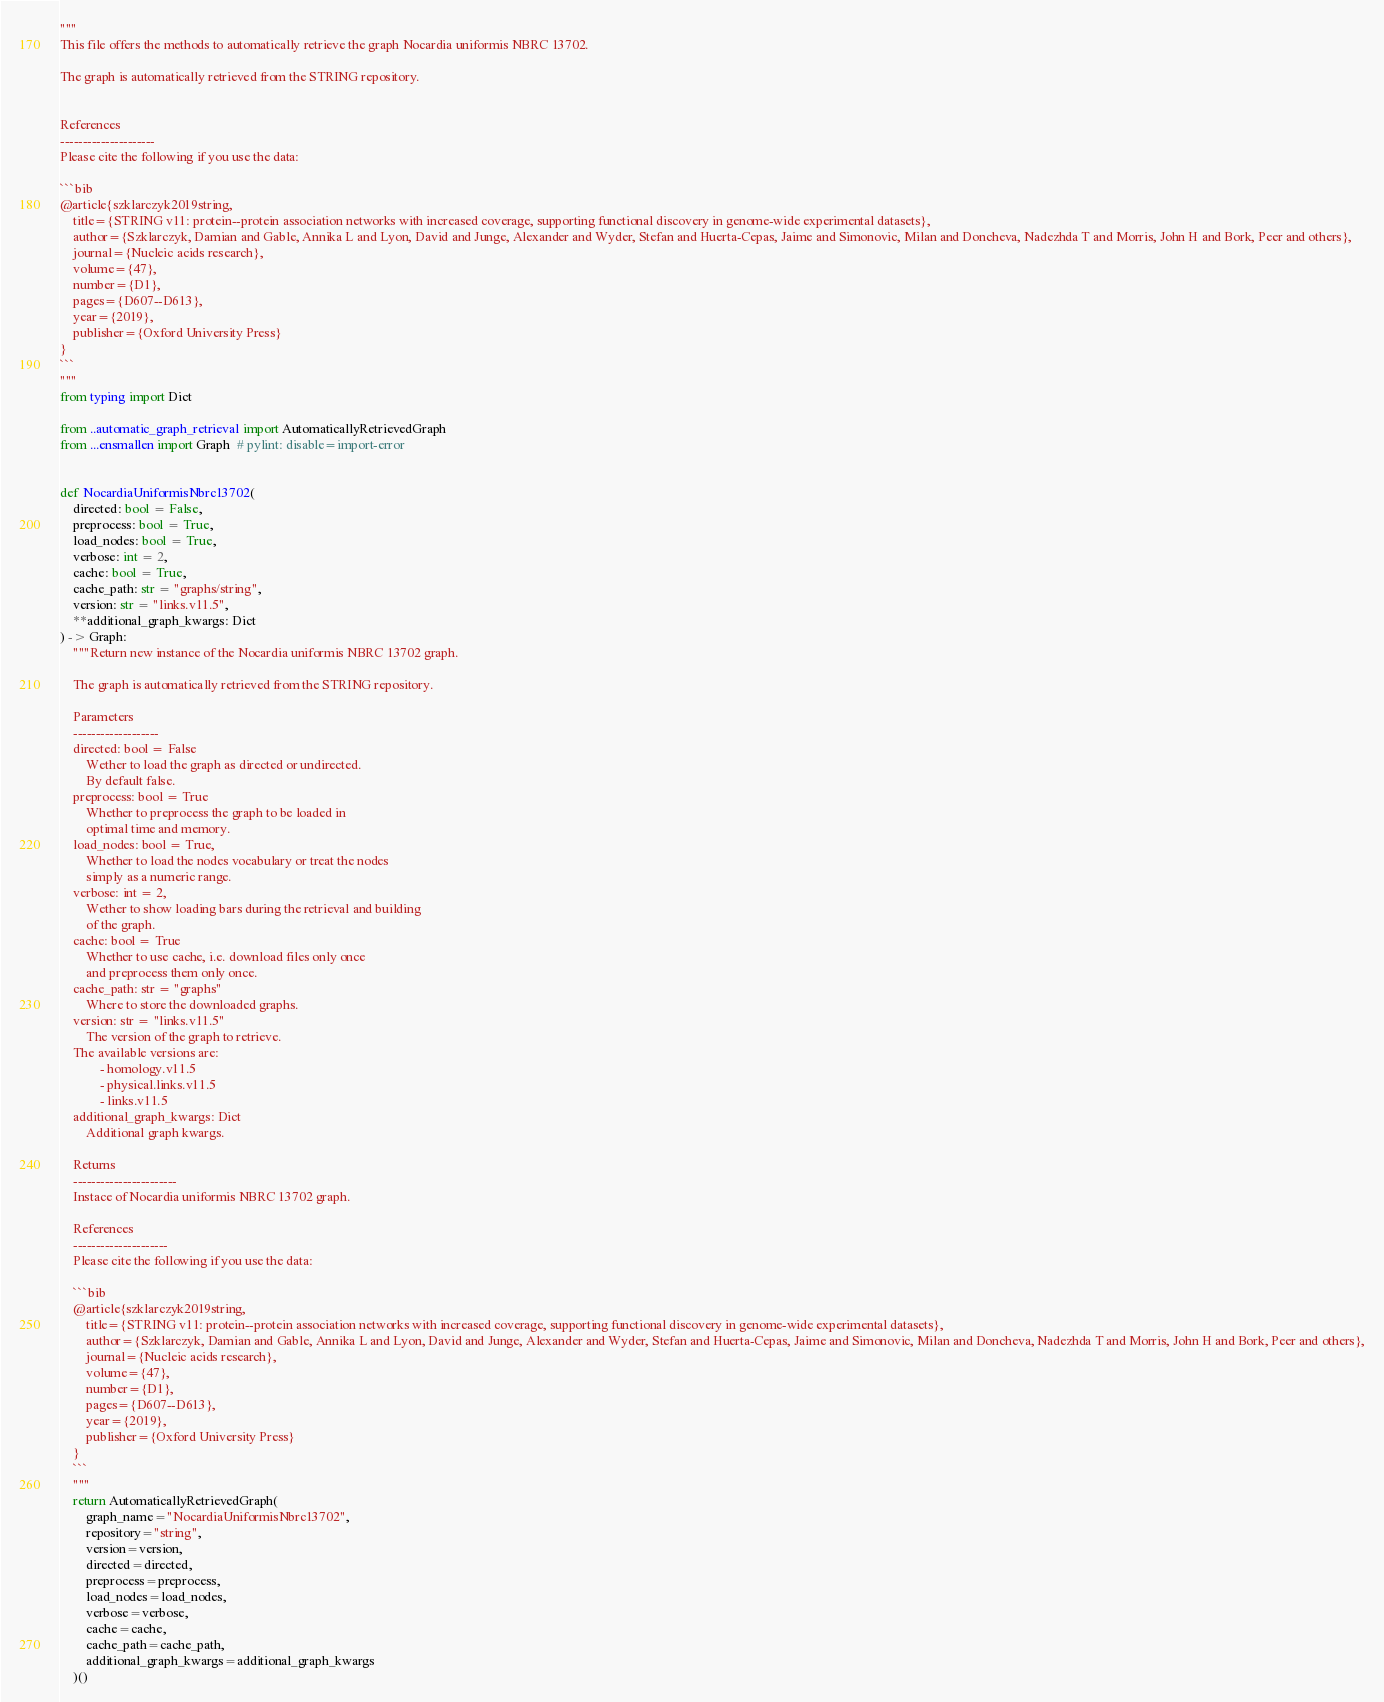<code> <loc_0><loc_0><loc_500><loc_500><_Python_>"""
This file offers the methods to automatically retrieve the graph Nocardia uniformis NBRC 13702.

The graph is automatically retrieved from the STRING repository. 


References
---------------------
Please cite the following if you use the data:

```bib
@article{szklarczyk2019string,
    title={STRING v11: protein--protein association networks with increased coverage, supporting functional discovery in genome-wide experimental datasets},
    author={Szklarczyk, Damian and Gable, Annika L and Lyon, David and Junge, Alexander and Wyder, Stefan and Huerta-Cepas, Jaime and Simonovic, Milan and Doncheva, Nadezhda T and Morris, John H and Bork, Peer and others},
    journal={Nucleic acids research},
    volume={47},
    number={D1},
    pages={D607--D613},
    year={2019},
    publisher={Oxford University Press}
}
```
"""
from typing import Dict

from ..automatic_graph_retrieval import AutomaticallyRetrievedGraph
from ...ensmallen import Graph  # pylint: disable=import-error


def NocardiaUniformisNbrc13702(
    directed: bool = False,
    preprocess: bool = True,
    load_nodes: bool = True,
    verbose: int = 2,
    cache: bool = True,
    cache_path: str = "graphs/string",
    version: str = "links.v11.5",
    **additional_graph_kwargs: Dict
) -> Graph:
    """Return new instance of the Nocardia uniformis NBRC 13702 graph.

    The graph is automatically retrieved from the STRING repository.	

    Parameters
    -------------------
    directed: bool = False
        Wether to load the graph as directed or undirected.
        By default false.
    preprocess: bool = True
        Whether to preprocess the graph to be loaded in 
        optimal time and memory.
    load_nodes: bool = True,
        Whether to load the nodes vocabulary or treat the nodes
        simply as a numeric range.
    verbose: int = 2,
        Wether to show loading bars during the retrieval and building
        of the graph.
    cache: bool = True
        Whether to use cache, i.e. download files only once
        and preprocess them only once.
    cache_path: str = "graphs"
        Where to store the downloaded graphs.
    version: str = "links.v11.5"
        The version of the graph to retrieve.		
	The available versions are:
			- homology.v11.5
			- physical.links.v11.5
			- links.v11.5
    additional_graph_kwargs: Dict
        Additional graph kwargs.

    Returns
    -----------------------
    Instace of Nocardia uniformis NBRC 13702 graph.

	References
	---------------------
	Please cite the following if you use the data:
	
	```bib
	@article{szklarczyk2019string,
	    title={STRING v11: protein--protein association networks with increased coverage, supporting functional discovery in genome-wide experimental datasets},
	    author={Szklarczyk, Damian and Gable, Annika L and Lyon, David and Junge, Alexander and Wyder, Stefan and Huerta-Cepas, Jaime and Simonovic, Milan and Doncheva, Nadezhda T and Morris, John H and Bork, Peer and others},
	    journal={Nucleic acids research},
	    volume={47},
	    number={D1},
	    pages={D607--D613},
	    year={2019},
	    publisher={Oxford University Press}
	}
	```
    """
    return AutomaticallyRetrievedGraph(
        graph_name="NocardiaUniformisNbrc13702",
        repository="string",
        version=version,
        directed=directed,
        preprocess=preprocess,
        load_nodes=load_nodes,
        verbose=verbose,
        cache=cache,
        cache_path=cache_path,
        additional_graph_kwargs=additional_graph_kwargs
    )()
</code> 